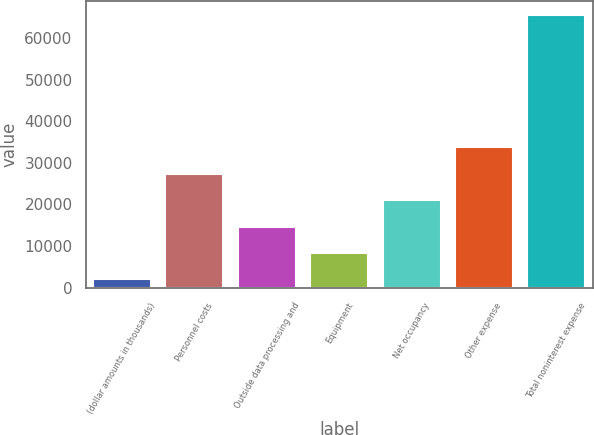Convert chart. <chart><loc_0><loc_0><loc_500><loc_500><bar_chart><fcel>(dollar amounts in thousands)<fcel>Personnel costs<fcel>Outside data processing and<fcel>Equipment<fcel>Net occupancy<fcel>Other expense<fcel>Total noninterest expense<nl><fcel>2014<fcel>27401.6<fcel>14707.8<fcel>8360.9<fcel>21054.7<fcel>33748.5<fcel>65483<nl></chart> 